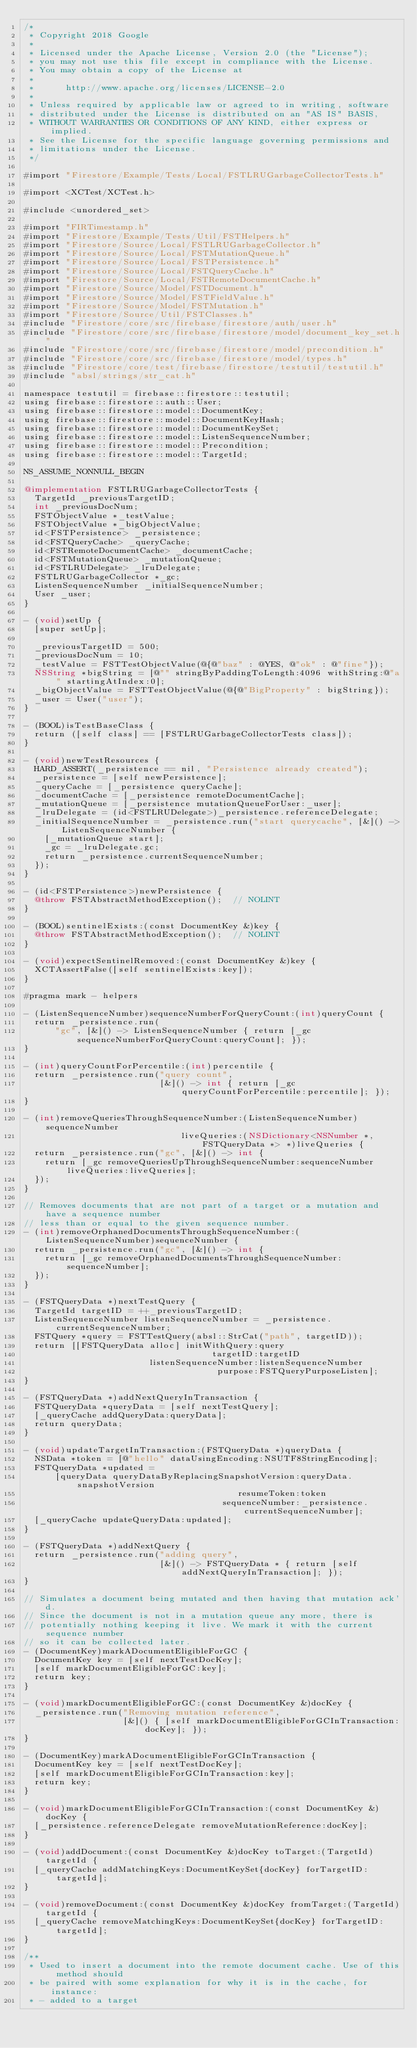Convert code to text. <code><loc_0><loc_0><loc_500><loc_500><_ObjectiveC_>/*
 * Copyright 2018 Google
 *
 * Licensed under the Apache License, Version 2.0 (the "License");
 * you may not use this file except in compliance with the License.
 * You may obtain a copy of the License at
 *
 *      http://www.apache.org/licenses/LICENSE-2.0
 *
 * Unless required by applicable law or agreed to in writing, software
 * distributed under the License is distributed on an "AS IS" BASIS,
 * WITHOUT WARRANTIES OR CONDITIONS OF ANY KIND, either express or implied.
 * See the License for the specific language governing permissions and
 * limitations under the License.
 */

#import "Firestore/Example/Tests/Local/FSTLRUGarbageCollectorTests.h"

#import <XCTest/XCTest.h>

#include <unordered_set>

#import "FIRTimestamp.h"
#import "Firestore/Example/Tests/Util/FSTHelpers.h"
#import "Firestore/Source/Local/FSTLRUGarbageCollector.h"
#import "Firestore/Source/Local/FSTMutationQueue.h"
#import "Firestore/Source/Local/FSTPersistence.h"
#import "Firestore/Source/Local/FSTQueryCache.h"
#import "Firestore/Source/Local/FSTRemoteDocumentCache.h"
#import "Firestore/Source/Model/FSTDocument.h"
#import "Firestore/Source/Model/FSTFieldValue.h"
#import "Firestore/Source/Model/FSTMutation.h"
#import "Firestore/Source/Util/FSTClasses.h"
#include "Firestore/core/src/firebase/firestore/auth/user.h"
#include "Firestore/core/src/firebase/firestore/model/document_key_set.h"
#include "Firestore/core/src/firebase/firestore/model/precondition.h"
#include "Firestore/core/src/firebase/firestore/model/types.h"
#include "Firestore/core/test/firebase/firestore/testutil/testutil.h"
#include "absl/strings/str_cat.h"

namespace testutil = firebase::firestore::testutil;
using firebase::firestore::auth::User;
using firebase::firestore::model::DocumentKey;
using firebase::firestore::model::DocumentKeyHash;
using firebase::firestore::model::DocumentKeySet;
using firebase::firestore::model::ListenSequenceNumber;
using firebase::firestore::model::Precondition;
using firebase::firestore::model::TargetId;

NS_ASSUME_NONNULL_BEGIN

@implementation FSTLRUGarbageCollectorTests {
  TargetId _previousTargetID;
  int _previousDocNum;
  FSTObjectValue *_testValue;
  FSTObjectValue *_bigObjectValue;
  id<FSTPersistence> _persistence;
  id<FSTQueryCache> _queryCache;
  id<FSTRemoteDocumentCache> _documentCache;
  id<FSTMutationQueue> _mutationQueue;
  id<FSTLRUDelegate> _lruDelegate;
  FSTLRUGarbageCollector *_gc;
  ListenSequenceNumber _initialSequenceNumber;
  User _user;
}

- (void)setUp {
  [super setUp];

  _previousTargetID = 500;
  _previousDocNum = 10;
  _testValue = FSTTestObjectValue(@{@"baz" : @YES, @"ok" : @"fine"});
  NSString *bigString = [@"" stringByPaddingToLength:4096 withString:@"a" startingAtIndex:0];
  _bigObjectValue = FSTTestObjectValue(@{@"BigProperty" : bigString});
  _user = User("user");
}

- (BOOL)isTestBaseClass {
  return ([self class] == [FSTLRUGarbageCollectorTests class]);
}

- (void)newTestResources {
  HARD_ASSERT(_persistence == nil, "Persistence already created");
  _persistence = [self newPersistence];
  _queryCache = [_persistence queryCache];
  _documentCache = [_persistence remoteDocumentCache];
  _mutationQueue = [_persistence mutationQueueForUser:_user];
  _lruDelegate = (id<FSTLRUDelegate>)_persistence.referenceDelegate;
  _initialSequenceNumber = _persistence.run("start querycache", [&]() -> ListenSequenceNumber {
    [_mutationQueue start];
    _gc = _lruDelegate.gc;
    return _persistence.currentSequenceNumber;
  });
}

- (id<FSTPersistence>)newPersistence {
  @throw FSTAbstractMethodException();  // NOLINT
}

- (BOOL)sentinelExists:(const DocumentKey &)key {
  @throw FSTAbstractMethodException();  // NOLINT
}

- (void)expectSentinelRemoved:(const DocumentKey &)key {
  XCTAssertFalse([self sentinelExists:key]);
}

#pragma mark - helpers

- (ListenSequenceNumber)sequenceNumberForQueryCount:(int)queryCount {
  return _persistence.run(
      "gc", [&]() -> ListenSequenceNumber { return [_gc sequenceNumberForQueryCount:queryCount]; });
}

- (int)queryCountForPercentile:(int)percentile {
  return _persistence.run("query count",
                          [&]() -> int { return [_gc queryCountForPercentile:percentile]; });
}

- (int)removeQueriesThroughSequenceNumber:(ListenSequenceNumber)sequenceNumber
                              liveQueries:(NSDictionary<NSNumber *, FSTQueryData *> *)liveQueries {
  return _persistence.run("gc", [&]() -> int {
    return [_gc removeQueriesUpThroughSequenceNumber:sequenceNumber liveQueries:liveQueries];
  });
}

// Removes documents that are not part of a target or a mutation and have a sequence number
// less than or equal to the given sequence number.
- (int)removeOrphanedDocumentsThroughSequenceNumber:(ListenSequenceNumber)sequenceNumber {
  return _persistence.run("gc", [&]() -> int {
    return [_gc removeOrphanedDocumentsThroughSequenceNumber:sequenceNumber];
  });
}

- (FSTQueryData *)nextTestQuery {
  TargetId targetID = ++_previousTargetID;
  ListenSequenceNumber listenSequenceNumber = _persistence.currentSequenceNumber;
  FSTQuery *query = FSTTestQuery(absl::StrCat("path", targetID));
  return [[FSTQueryData alloc] initWithQuery:query
                                    targetID:targetID
                        listenSequenceNumber:listenSequenceNumber
                                     purpose:FSTQueryPurposeListen];
}

- (FSTQueryData *)addNextQueryInTransaction {
  FSTQueryData *queryData = [self nextTestQuery];
  [_queryCache addQueryData:queryData];
  return queryData;
}

- (void)updateTargetInTransaction:(FSTQueryData *)queryData {
  NSData *token = [@"hello" dataUsingEncoding:NSUTF8StringEncoding];
  FSTQueryData *updated =
      [queryData queryDataByReplacingSnapshotVersion:queryData.snapshotVersion
                                         resumeToken:token
                                      sequenceNumber:_persistence.currentSequenceNumber];
  [_queryCache updateQueryData:updated];
}

- (FSTQueryData *)addNextQuery {
  return _persistence.run("adding query",
                          [&]() -> FSTQueryData * { return [self addNextQueryInTransaction]; });
}

// Simulates a document being mutated and then having that mutation ack'd.
// Since the document is not in a mutation queue any more, there is
// potentially nothing keeping it live. We mark it with the current sequence number
// so it can be collected later.
- (DocumentKey)markADocumentEligibleForGC {
  DocumentKey key = [self nextTestDocKey];
  [self markDocumentEligibleForGC:key];
  return key;
}

- (void)markDocumentEligibleForGC:(const DocumentKey &)docKey {
  _persistence.run("Removing mutation reference",
                   [&]() { [self markDocumentEligibleForGCInTransaction:docKey]; });
}

- (DocumentKey)markADocumentEligibleForGCInTransaction {
  DocumentKey key = [self nextTestDocKey];
  [self markDocumentEligibleForGCInTransaction:key];
  return key;
}

- (void)markDocumentEligibleForGCInTransaction:(const DocumentKey &)docKey {
  [_persistence.referenceDelegate removeMutationReference:docKey];
}

- (void)addDocument:(const DocumentKey &)docKey toTarget:(TargetId)targetId {
  [_queryCache addMatchingKeys:DocumentKeySet{docKey} forTargetID:targetId];
}

- (void)removeDocument:(const DocumentKey &)docKey fromTarget:(TargetId)targetId {
  [_queryCache removeMatchingKeys:DocumentKeySet{docKey} forTargetID:targetId];
}

/**
 * Used to insert a document into the remote document cache. Use of this method should
 * be paired with some explanation for why it is in the cache, for instance:
 * - added to a target</code> 